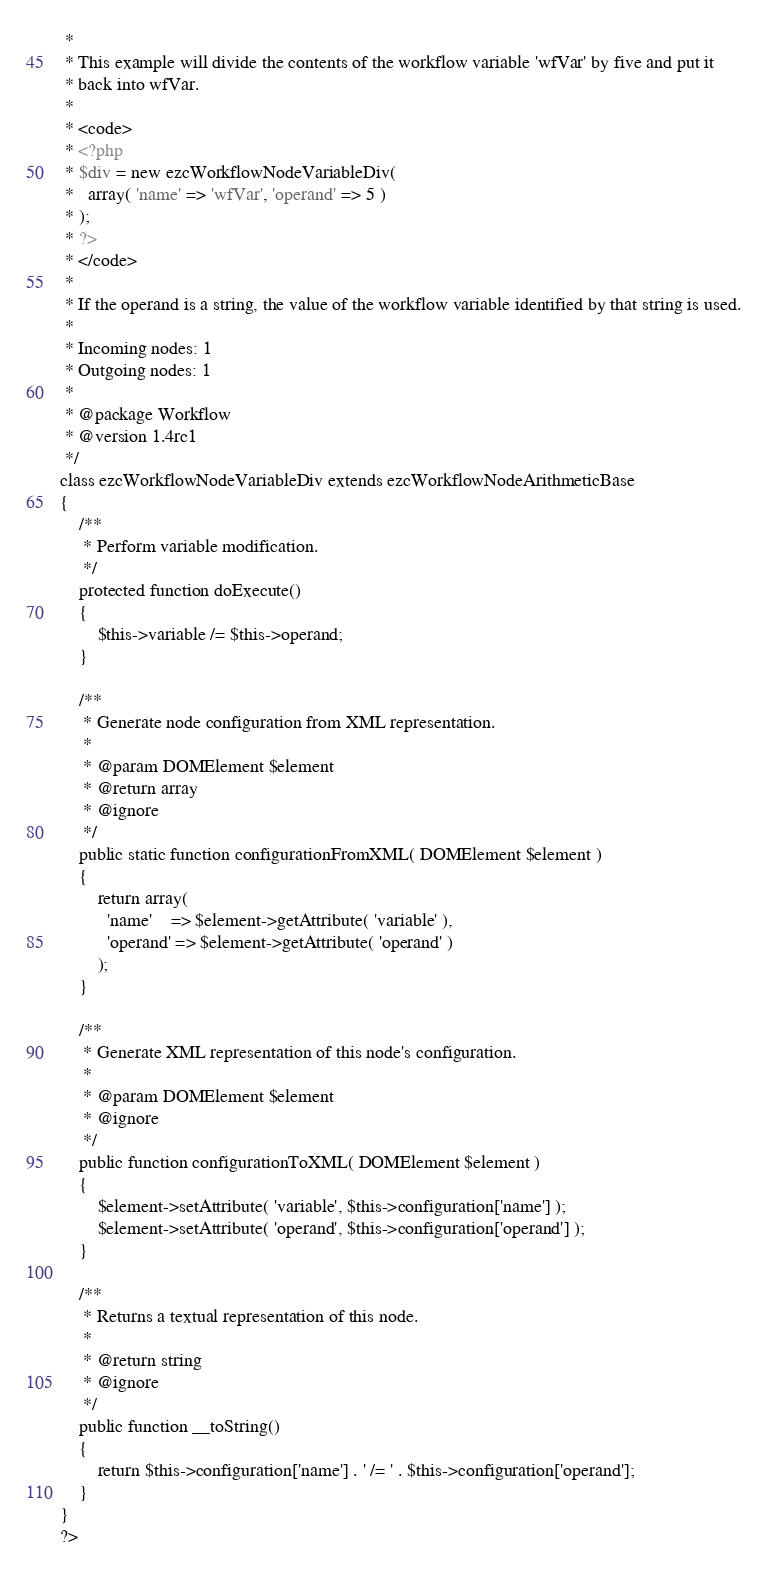Convert code to text. <code><loc_0><loc_0><loc_500><loc_500><_PHP_> *
 * This example will divide the contents of the workflow variable 'wfVar' by five and put it
 * back into wfVar.
 *
 * <code>
 * <?php
 * $div = new ezcWorkflowNodeVariableDiv(
 *   array( 'name' => 'wfVar', 'operand' => 5 )
 * );
 * ?>
 * </code>
 *
 * If the operand is a string, the value of the workflow variable identified by that string is used.
 *
 * Incoming nodes: 1
 * Outgoing nodes: 1
 *
 * @package Workflow
 * @version 1.4rc1
 */
class ezcWorkflowNodeVariableDiv extends ezcWorkflowNodeArithmeticBase
{
    /**
     * Perform variable modification.
     */
    protected function doExecute()
    {
        $this->variable /= $this->operand;
    }

    /**
     * Generate node configuration from XML representation.
     *
     * @param DOMElement $element
     * @return array
     * @ignore
     */
    public static function configurationFromXML( DOMElement $element )
    {
        return array(
          'name'    => $element->getAttribute( 'variable' ),
          'operand' => $element->getAttribute( 'operand' )
        );
    }

    /**
     * Generate XML representation of this node's configuration.
     *
     * @param DOMElement $element
     * @ignore
     */
    public function configurationToXML( DOMElement $element )
    {
        $element->setAttribute( 'variable', $this->configuration['name'] );
        $element->setAttribute( 'operand', $this->configuration['operand'] );
    }

    /**
     * Returns a textual representation of this node.
     *
     * @return string
     * @ignore
     */
    public function __toString()
    {
        return $this->configuration['name'] . ' /= ' . $this->configuration['operand'];
    }
}
?>
</code> 